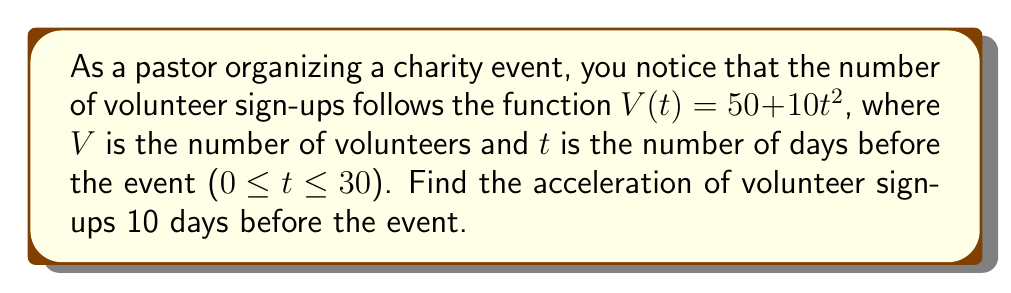What is the answer to this math problem? To find the acceleration of volunteer sign-ups, we need to calculate the second derivative of the given function $V(t)$.

Step 1: The original function is $V(t) = 50 + 10t^2$

Step 2: Calculate the first derivative (velocity of sign-ups)
$$\frac{dV}{dt} = V'(t) = 20t$$

Step 3: Calculate the second derivative (acceleration of sign-ups)
$$\frac{d^2V}{dt^2} = V''(t) = 20$$

Step 4: The acceleration is constant at 20 volunteers per day squared, regardless of the time.

Therefore, 10 days before the event (or at any other time), the acceleration of volunteer sign-ups is 20 volunteers per day squared.
Answer: 20 volunteers/day² 